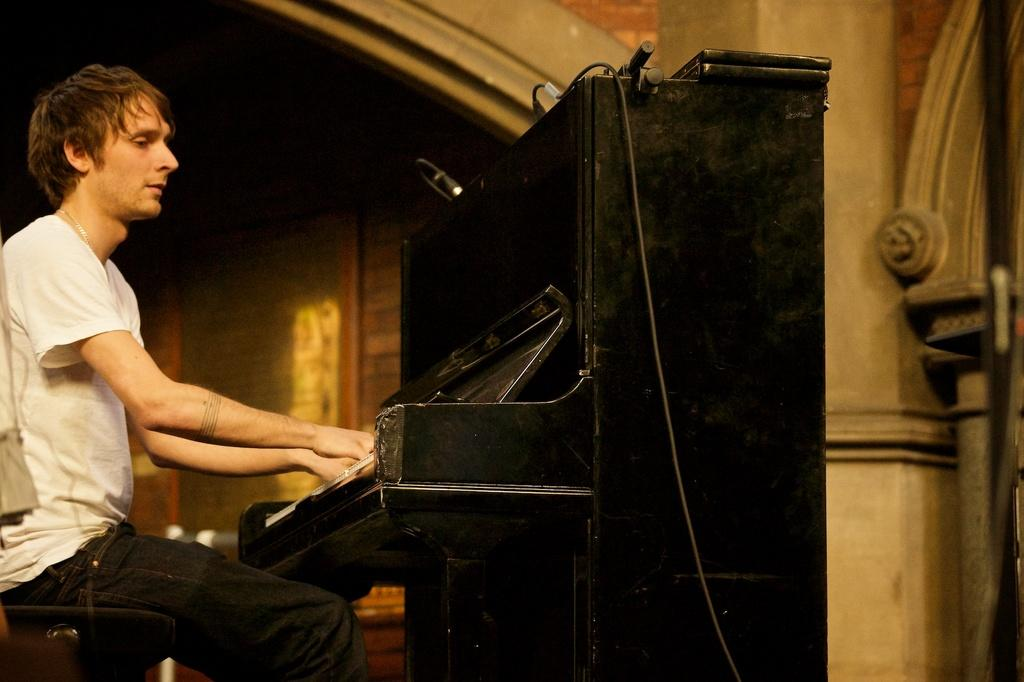Who is the person in the image? There is a man in the image. What is the man wearing? The man is wearing a white t-shirt. What is the man doing in the image? The man is sitting on a chair and playing the piano. Where is the piano located in relation to the man? The piano is in front of the man. How many ants can be seen crawling on the piano in the image? There are no ants visible in the image; it only shows a man playing the piano. 